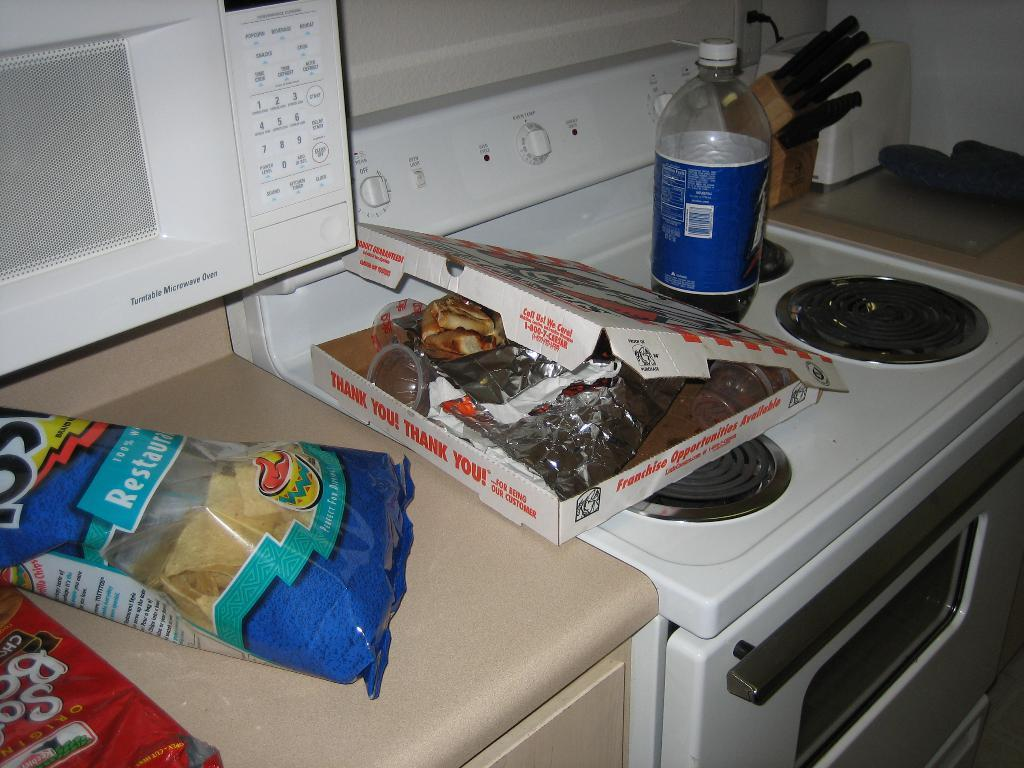Provide a one-sentence caption for the provided image. garbage on a kitchen counter including a pizza box that reads Thank You. 